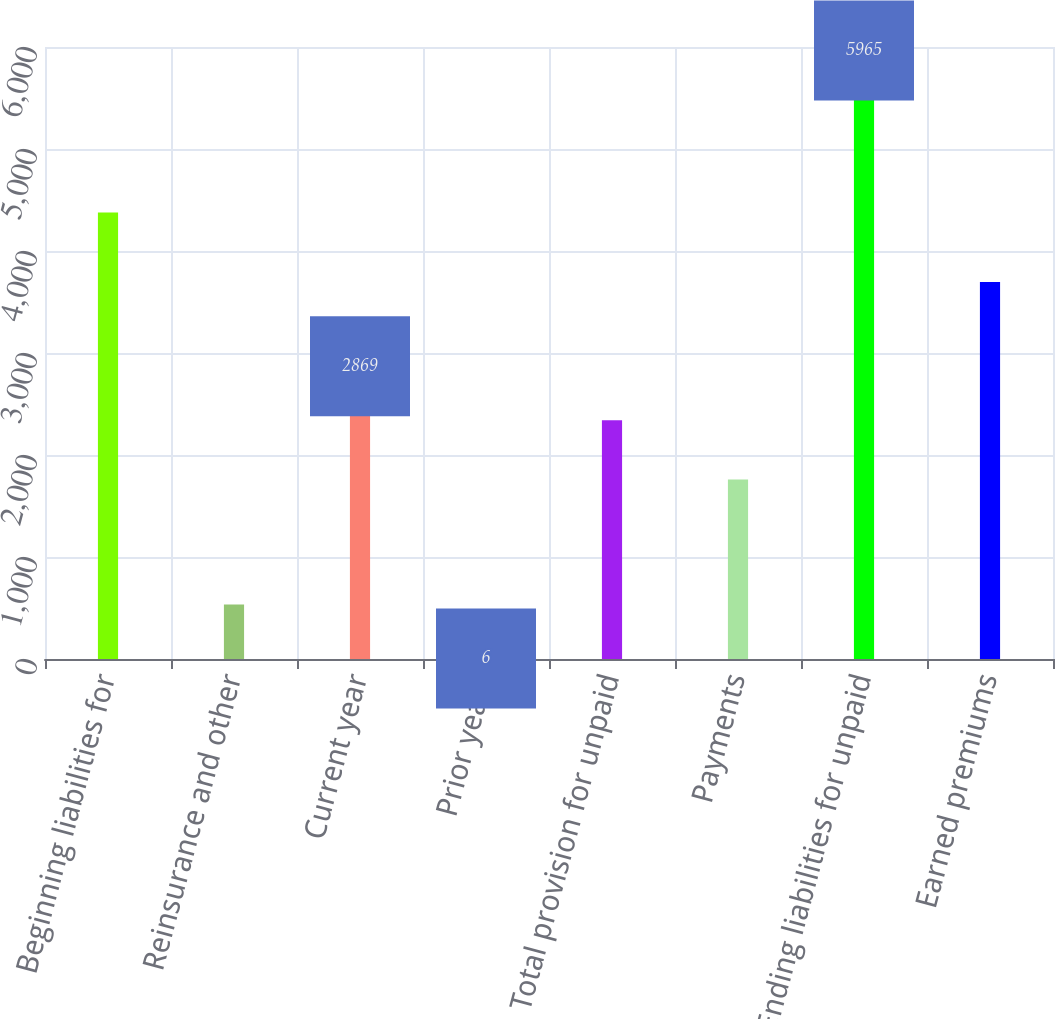Convert chart. <chart><loc_0><loc_0><loc_500><loc_500><bar_chart><fcel>Beginning liabilities for<fcel>Reinsurance and other<fcel>Current year<fcel>Prior years<fcel>Total provision for unpaid<fcel>Payments<fcel>Ending liabilities for unpaid<fcel>Earned premiums<nl><fcel>4378<fcel>535<fcel>2869<fcel>6<fcel>2340<fcel>1761<fcel>5965<fcel>3696<nl></chart> 